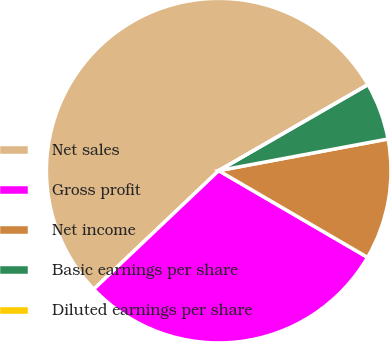<chart> <loc_0><loc_0><loc_500><loc_500><pie_chart><fcel>Net sales<fcel>Gross profit<fcel>Net income<fcel>Basic earnings per share<fcel>Diluted earnings per share<nl><fcel>53.76%<fcel>29.53%<fcel>11.34%<fcel>5.38%<fcel>0.0%<nl></chart> 